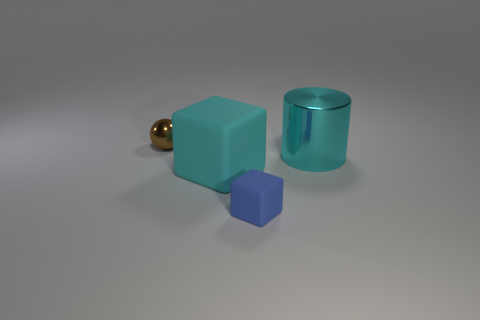Add 4 cyan metal cylinders. How many objects exist? 8 Subtract all cylinders. How many objects are left? 3 Add 3 small cyan cubes. How many small cyan cubes exist? 3 Subtract 1 cyan blocks. How many objects are left? 3 Subtract all brown cubes. Subtract all matte cubes. How many objects are left? 2 Add 3 big cyan objects. How many big cyan objects are left? 5 